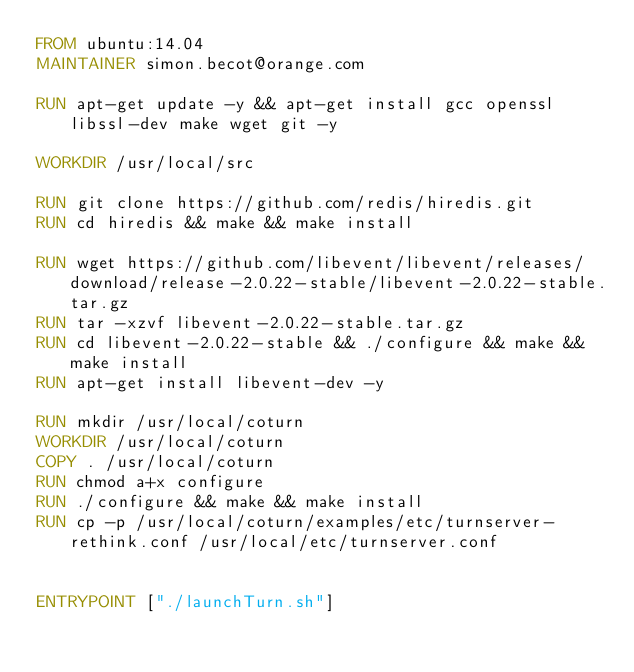Convert code to text. <code><loc_0><loc_0><loc_500><loc_500><_Dockerfile_>FROM ubuntu:14.04
MAINTAINER simon.becot@orange.com

RUN apt-get update -y && apt-get install gcc openssl libssl-dev make wget git -y

WORKDIR /usr/local/src

RUN git clone https://github.com/redis/hiredis.git
RUN cd hiredis && make && make install

RUN wget https://github.com/libevent/libevent/releases/download/release-2.0.22-stable/libevent-2.0.22-stable.tar.gz
RUN tar -xzvf libevent-2.0.22-stable.tar.gz
RUN cd libevent-2.0.22-stable && ./configure && make && make install
RUN apt-get install libevent-dev -y

RUN mkdir /usr/local/coturn
WORKDIR /usr/local/coturn
COPY . /usr/local/coturn
RUN chmod a+x configure
RUN ./configure && make && make install
RUN cp -p /usr/local/coturn/examples/etc/turnserver-rethink.conf /usr/local/etc/turnserver.conf


ENTRYPOINT ["./launchTurn.sh"]


</code> 